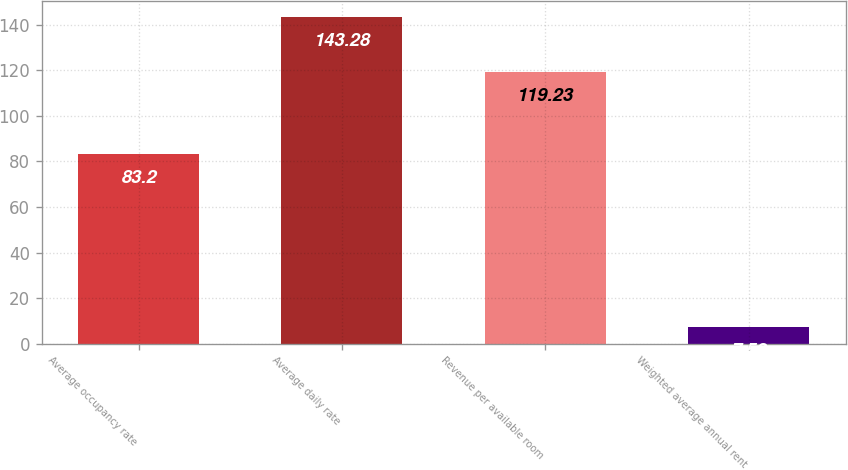Convert chart. <chart><loc_0><loc_0><loc_500><loc_500><bar_chart><fcel>Average occupancy rate<fcel>Average daily rate<fcel>Revenue per available room<fcel>Weighted average annual rent<nl><fcel>83.2<fcel>143.28<fcel>119.23<fcel>7.52<nl></chart> 